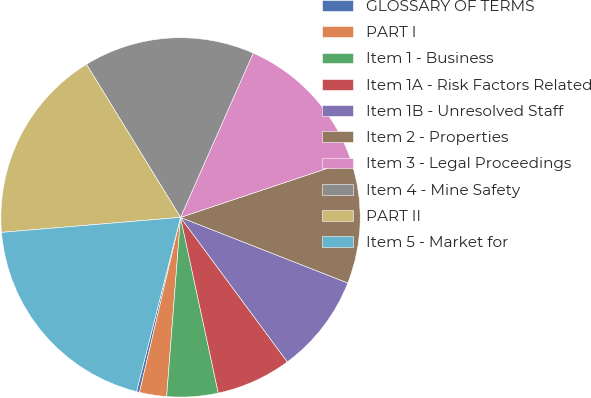Convert chart to OTSL. <chart><loc_0><loc_0><loc_500><loc_500><pie_chart><fcel>GLOSSARY OF TERMS<fcel>PART I<fcel>Item 1 - Business<fcel>Item 1A - Risk Factors Related<fcel>Item 1B - Unresolved Staff<fcel>Item 2 - Properties<fcel>Item 3 - Legal Proceedings<fcel>Item 4 - Mine Safety<fcel>PART II<fcel>Item 5 - Market for<nl><fcel>0.27%<fcel>2.44%<fcel>4.6%<fcel>6.76%<fcel>8.92%<fcel>11.08%<fcel>13.24%<fcel>15.4%<fcel>17.56%<fcel>19.73%<nl></chart> 